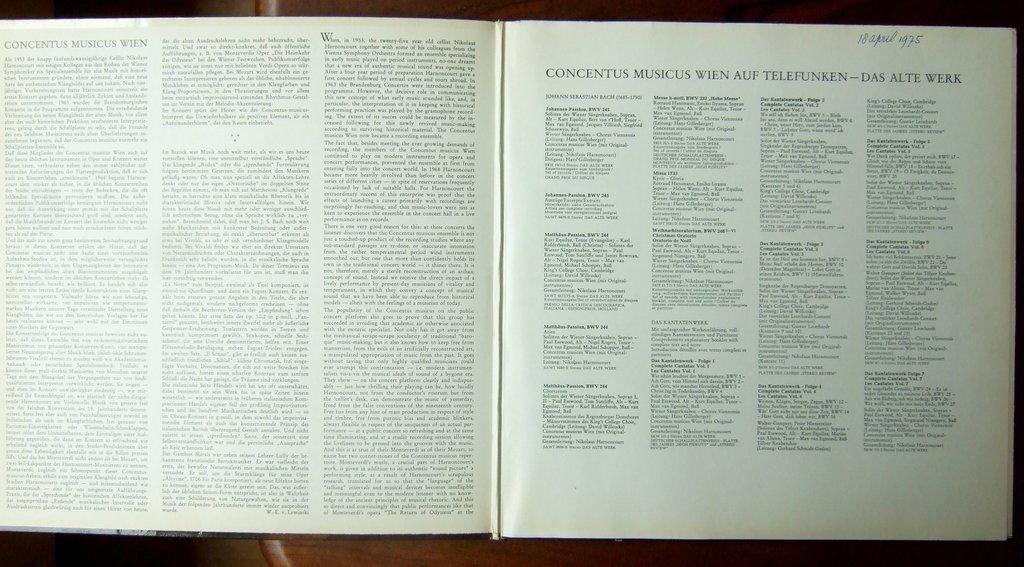<image>
Describe the image concisely. an open book page that says 'concentus musicus wien' 